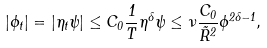Convert formula to latex. <formula><loc_0><loc_0><loc_500><loc_500>| \phi _ { t } | = | \eta _ { t } \psi | \leq C _ { 0 } \frac { 1 } { T } \eta ^ { \delta } \psi \leq \nu \frac { C _ { 0 } } { \tilde { R } ^ { 2 } } \phi ^ { 2 \delta - 1 } ,</formula> 